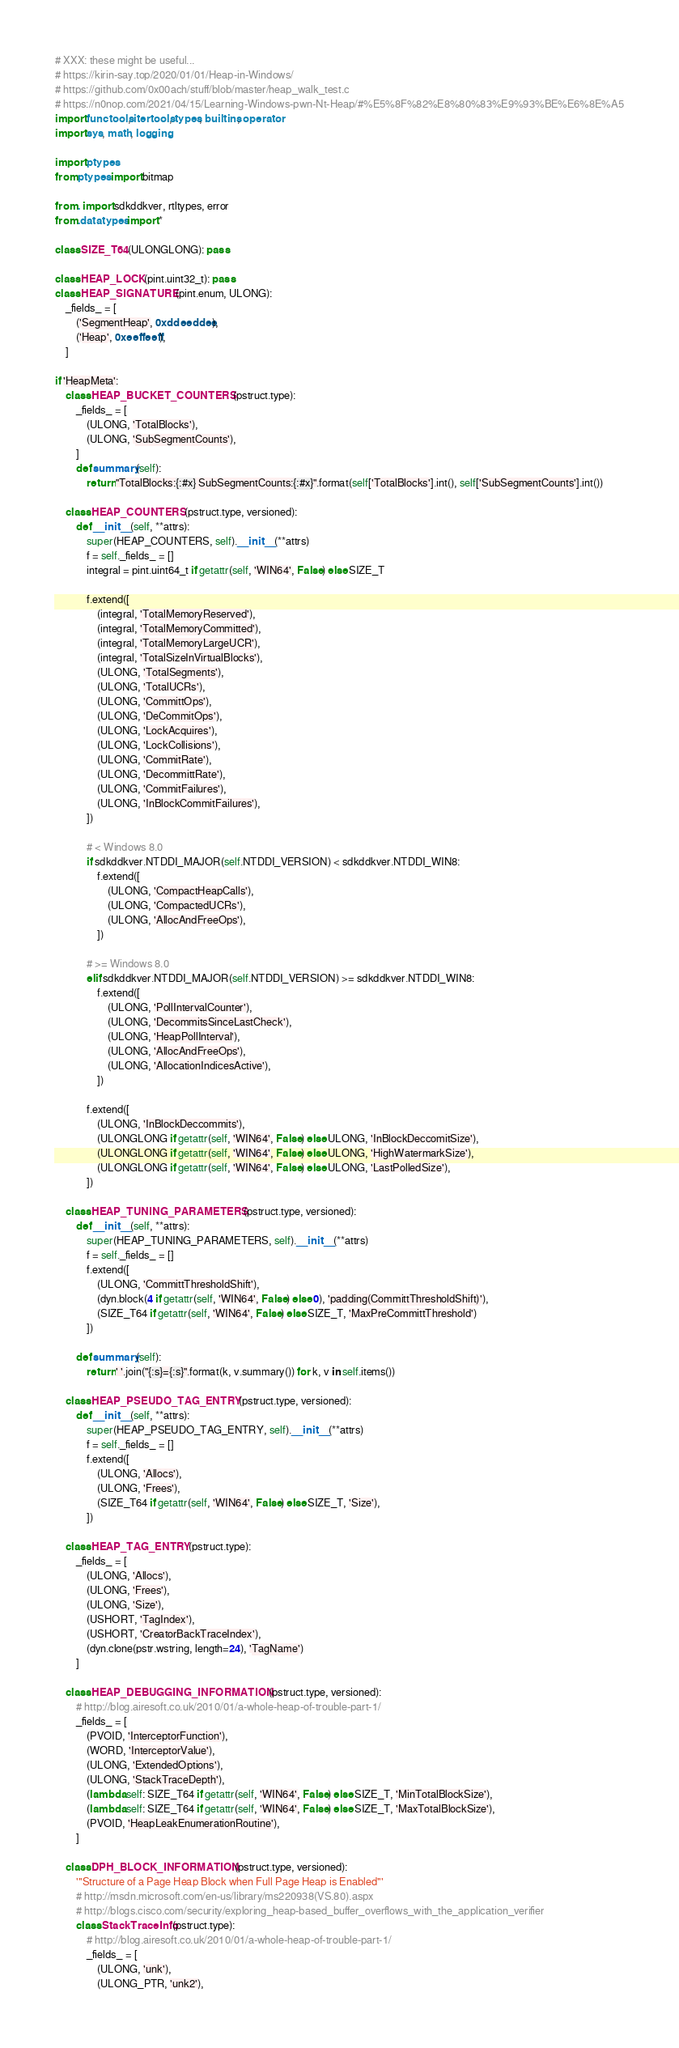<code> <loc_0><loc_0><loc_500><loc_500><_Python_># XXX: these might be useful...
# https://kirin-say.top/2020/01/01/Heap-in-Windows/
# https://github.com/0x00ach/stuff/blob/master/heap_walk_test.c
# https://n0nop.com/2021/04/15/Learning-Windows-pwn-Nt-Heap/#%E5%8F%82%E8%80%83%E9%93%BE%E6%8E%A5
import functools, itertools, types, builtins, operator
import sys, math, logging

import ptypes
from ptypes import bitmap

from . import sdkddkver, rtltypes, error
from .datatypes import *

class SIZE_T64(ULONGLONG): pass

class HEAP_LOCK(pint.uint32_t): pass
class HEAP_SIGNATURE(pint.enum, ULONG):
    _fields_ = [
        ('SegmentHeap', 0xddeeddee),
        ('Heap', 0xeeffeeff),
    ]

if 'HeapMeta':
    class HEAP_BUCKET_COUNTERS(pstruct.type):
        _fields_ = [
            (ULONG, 'TotalBlocks'),
            (ULONG, 'SubSegmentCounts'),
        ]
        def summary(self):
            return "TotalBlocks:{:#x} SubSegmentCounts:{:#x}".format(self['TotalBlocks'].int(), self['SubSegmentCounts'].int())

    class HEAP_COUNTERS(pstruct.type, versioned):
        def __init__(self, **attrs):
            super(HEAP_COUNTERS, self).__init__(**attrs)
            f = self._fields_ = []
            integral = pint.uint64_t if getattr(self, 'WIN64', False) else SIZE_T

            f.extend([
                (integral, 'TotalMemoryReserved'),
                (integral, 'TotalMemoryCommitted'),
                (integral, 'TotalMemoryLargeUCR'),
                (integral, 'TotalSizeInVirtualBlocks'),
                (ULONG, 'TotalSegments'),
                (ULONG, 'TotalUCRs'),
                (ULONG, 'CommittOps'),
                (ULONG, 'DeCommitOps'),
                (ULONG, 'LockAcquires'),
                (ULONG, 'LockCollisions'),
                (ULONG, 'CommitRate'),
                (ULONG, 'DecommittRate'),
                (ULONG, 'CommitFailures'),
                (ULONG, 'InBlockCommitFailures'),
            ])

            # < Windows 8.0
            if sdkddkver.NTDDI_MAJOR(self.NTDDI_VERSION) < sdkddkver.NTDDI_WIN8:
                f.extend([
                    (ULONG, 'CompactHeapCalls'),
                    (ULONG, 'CompactedUCRs'),
                    (ULONG, 'AllocAndFreeOps'),
                ])

            # >= Windows 8.0
            elif sdkddkver.NTDDI_MAJOR(self.NTDDI_VERSION) >= sdkddkver.NTDDI_WIN8:
                f.extend([
                    (ULONG, 'PollIntervalCounter'),
                    (ULONG, 'DecommitsSinceLastCheck'),
                    (ULONG, 'HeapPollInterval'),
                    (ULONG, 'AllocAndFreeOps'),
                    (ULONG, 'AllocationIndicesActive'),
                ])

            f.extend([
                (ULONG, 'InBlockDeccommits'),
                (ULONGLONG if getattr(self, 'WIN64', False) else ULONG, 'InBlockDeccomitSize'),
                (ULONGLONG if getattr(self, 'WIN64', False) else ULONG, 'HighWatermarkSize'),
                (ULONGLONG if getattr(self, 'WIN64', False) else ULONG, 'LastPolledSize'),
            ])

    class HEAP_TUNING_PARAMETERS(pstruct.type, versioned):
        def __init__(self, **attrs):
            super(HEAP_TUNING_PARAMETERS, self).__init__(**attrs)
            f = self._fields_ = []
            f.extend([
                (ULONG, 'CommittThresholdShift'),
                (dyn.block(4 if getattr(self, 'WIN64', False) else 0), 'padding(CommittThresholdShift)'),
                (SIZE_T64 if getattr(self, 'WIN64', False) else SIZE_T, 'MaxPreCommittThreshold')
            ])

        def summary(self):
            return ' '.join("{:s}={:s}".format(k, v.summary()) for k, v in self.items())

    class HEAP_PSEUDO_TAG_ENTRY(pstruct.type, versioned):
        def __init__(self, **attrs):
            super(HEAP_PSEUDO_TAG_ENTRY, self).__init__(**attrs)
            f = self._fields_ = []
            f.extend([
                (ULONG, 'Allocs'),
                (ULONG, 'Frees'),
                (SIZE_T64 if getattr(self, 'WIN64', False) else SIZE_T, 'Size'),
            ])

    class HEAP_TAG_ENTRY(pstruct.type):
        _fields_ = [
            (ULONG, 'Allocs'),
            (ULONG, 'Frees'),
            (ULONG, 'Size'),
            (USHORT, 'TagIndex'),
            (USHORT, 'CreatorBackTraceIndex'),
            (dyn.clone(pstr.wstring, length=24), 'TagName')
        ]

    class HEAP_DEBUGGING_INFORMATION(pstruct.type, versioned):
        # http://blog.airesoft.co.uk/2010/01/a-whole-heap-of-trouble-part-1/
        _fields_ = [
            (PVOID, 'InterceptorFunction'),
            (WORD, 'InterceptorValue'),
            (ULONG, 'ExtendedOptions'),
            (ULONG, 'StackTraceDepth'),
            (lambda self: SIZE_T64 if getattr(self, 'WIN64', False) else SIZE_T, 'MinTotalBlockSize'),
            (lambda self: SIZE_T64 if getattr(self, 'WIN64', False) else SIZE_T, 'MaxTotalBlockSize'),
            (PVOID, 'HeapLeakEnumerationRoutine'),
        ]

    class DPH_BLOCK_INFORMATION(pstruct.type, versioned):
        '''Structure of a Page Heap Block when Full Page Heap is Enabled'''
        # http://msdn.microsoft.com/en-us/library/ms220938(VS.80).aspx
        # http://blogs.cisco.com/security/exploring_heap-based_buffer_overflows_with_the_application_verifier
        class StackTraceInfo(pstruct.type):
            # http://blog.airesoft.co.uk/2010/01/a-whole-heap-of-trouble-part-1/
            _fields_ = [
                (ULONG, 'unk'),
                (ULONG_PTR, 'unk2'),</code> 